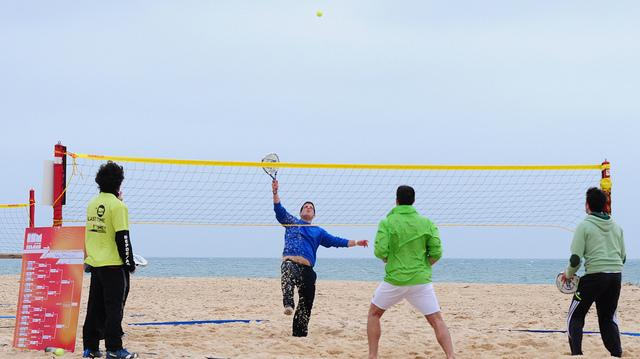What type of net is being played over? volleyball 